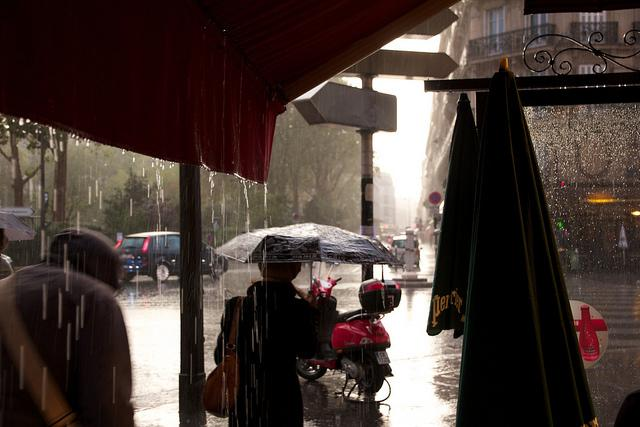Where does this water come from?

Choices:
A) hose
B) sky
C) water nozzle
D) fire hydrant sky 